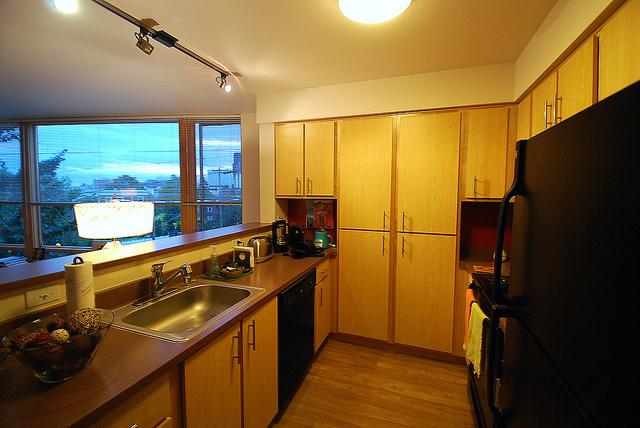What would a person at the sink be looking out towards?
Short answer required. City. Are the cabinets closed?
Short answer required. Yes. How many towels are hanging from the stove?
Write a very short answer. 2. 